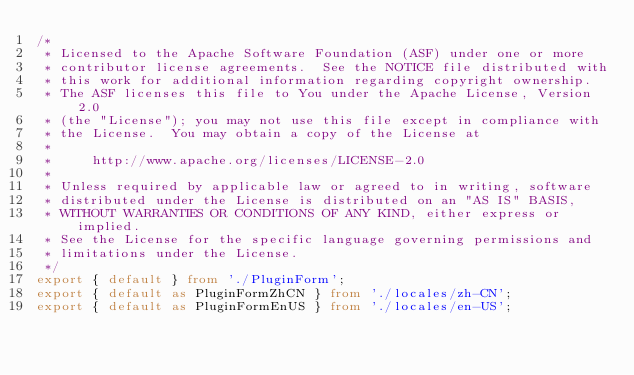<code> <loc_0><loc_0><loc_500><loc_500><_TypeScript_>/*
 * Licensed to the Apache Software Foundation (ASF) under one or more
 * contributor license agreements.  See the NOTICE file distributed with
 * this work for additional information regarding copyright ownership.
 * The ASF licenses this file to You under the Apache License, Version 2.0
 * (the "License"); you may not use this file except in compliance with
 * the License.  You may obtain a copy of the License at
 *
 *     http://www.apache.org/licenses/LICENSE-2.0
 *
 * Unless required by applicable law or agreed to in writing, software
 * distributed under the License is distributed on an "AS IS" BASIS,
 * WITHOUT WARRANTIES OR CONDITIONS OF ANY KIND, either express or implied.
 * See the License for the specific language governing permissions and
 * limitations under the License.
 */
export { default } from './PluginForm';
export { default as PluginFormZhCN } from './locales/zh-CN';
export { default as PluginFormEnUS } from './locales/en-US';
</code> 